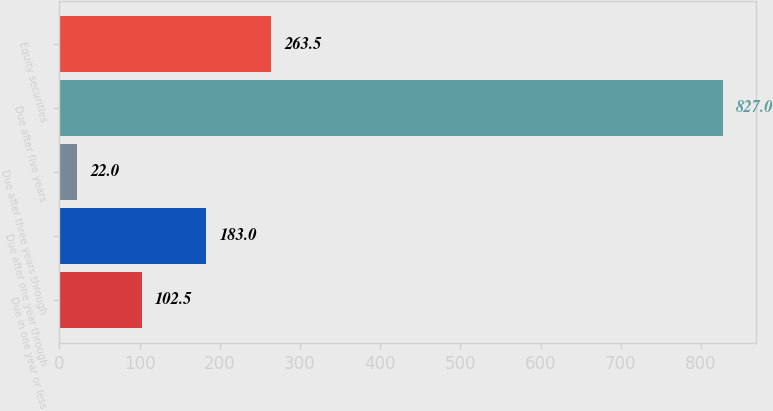Convert chart. <chart><loc_0><loc_0><loc_500><loc_500><bar_chart><fcel>Due in one year or less<fcel>Due after one year through<fcel>Due after three years through<fcel>Due after five years<fcel>Equity securities<nl><fcel>102.5<fcel>183<fcel>22<fcel>827<fcel>263.5<nl></chart> 